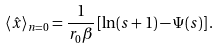Convert formula to latex. <formula><loc_0><loc_0><loc_500><loc_500>\langle \hat { x } \rangle _ { n = 0 } = \frac { 1 } { r _ { 0 } \beta } \left [ \ln ( s + 1 ) - \Psi ( s ) \right ] .</formula> 